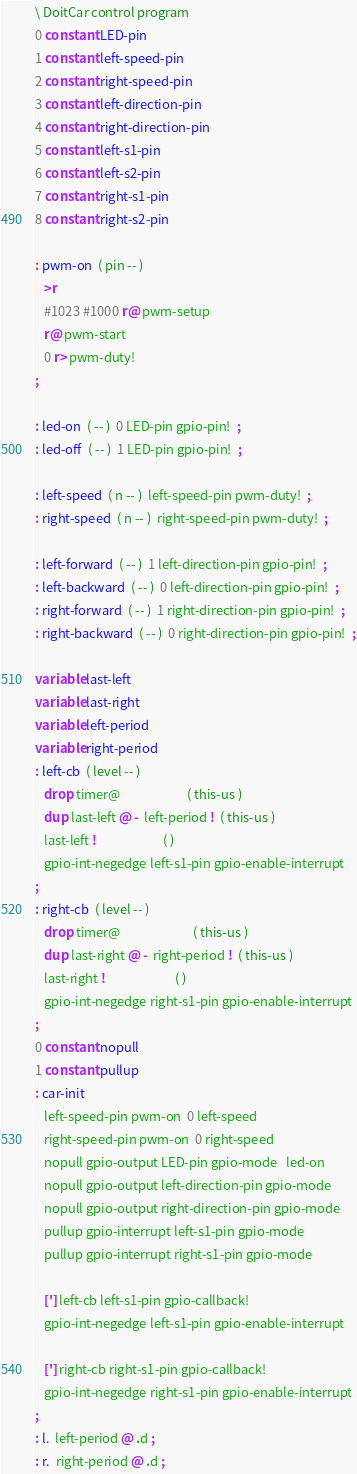Convert code to text. <code><loc_0><loc_0><loc_500><loc_500><_Forth_>\ DoitCar control program
0 constant LED-pin
1 constant left-speed-pin
2 constant right-speed-pin
3 constant left-direction-pin
4 constant right-direction-pin
5 constant left-s1-pin
6 constant left-s2-pin
7 constant right-s1-pin
8 constant right-s2-pin

: pwm-on  ( pin -- )
   >r
   #1023 #1000 r@ pwm-setup
   r@ pwm-start
   0 r> pwm-duty!
;

: led-on  ( -- )  0 LED-pin gpio-pin!  ;
: led-off  ( -- )  1 LED-pin gpio-pin!  ;

: left-speed  ( n -- )  left-speed-pin pwm-duty!  ;
: right-speed  ( n -- )  right-speed-pin pwm-duty!  ;

: left-forward  ( -- )  1 left-direction-pin gpio-pin!  ;
: left-backward  ( -- )  0 left-direction-pin gpio-pin!  ;
: right-forward  ( -- )  1 right-direction-pin gpio-pin!  ;
: right-backward  ( -- )  0 right-direction-pin gpio-pin!  ;

variable last-left
variable last-right
variable left-period
variable right-period
: left-cb  ( level -- )
   drop timer@                       ( this-us )
   dup last-left @ -  left-period !  ( this-us )
   last-left !                       ( )
   gpio-int-negedge left-s1-pin gpio-enable-interrupt
;
: right-cb  ( level -- )
   drop timer@                         ( this-us )
   dup last-right @ -  right-period !  ( this-us )
   last-right !                        ( )
   gpio-int-negedge right-s1-pin gpio-enable-interrupt
;
0 constant nopull
1 constant pullup
: car-init
   left-speed-pin pwm-on  0 left-speed
   right-speed-pin pwm-on  0 right-speed
   nopull gpio-output LED-pin gpio-mode   led-on
   nopull gpio-output left-direction-pin gpio-mode
   nopull gpio-output right-direction-pin gpio-mode
   pullup gpio-interrupt left-s1-pin gpio-mode
   pullup gpio-interrupt right-s1-pin gpio-mode

   ['] left-cb left-s1-pin gpio-callback!
   gpio-int-negedge left-s1-pin gpio-enable-interrupt

   ['] right-cb right-s1-pin gpio-callback!
   gpio-int-negedge right-s1-pin gpio-enable-interrupt
;
: l.  left-period @ .d ;
: r.  right-period @ .d ;
</code> 